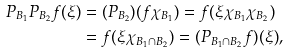Convert formula to latex. <formula><loc_0><loc_0><loc_500><loc_500>P _ { B _ { 1 } } P _ { B _ { 2 } } f ( \xi ) & = ( P _ { B _ { 2 } } ) ( f \chi _ { B _ { 1 } } ) = f ( \xi \chi _ { B _ { 1 } } \chi _ { B _ { 2 } } ) \\ & = f ( \xi \chi _ { B _ { 1 } \cap B _ { 2 } } ) = ( P _ { B _ { 1 } \cap B _ { 2 } } f ) ( \xi ) ,</formula> 